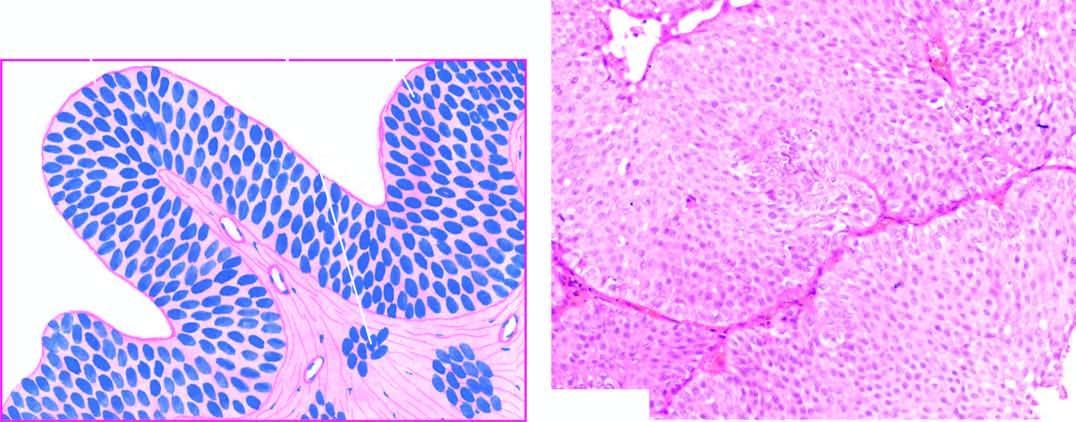re uclear features of malignant cells in malignant melanoma-pleomorphism, anisonucleosis, still recognisable as of transitional origin and show features of anaplasia?
Answer the question using a single word or phrase. No 